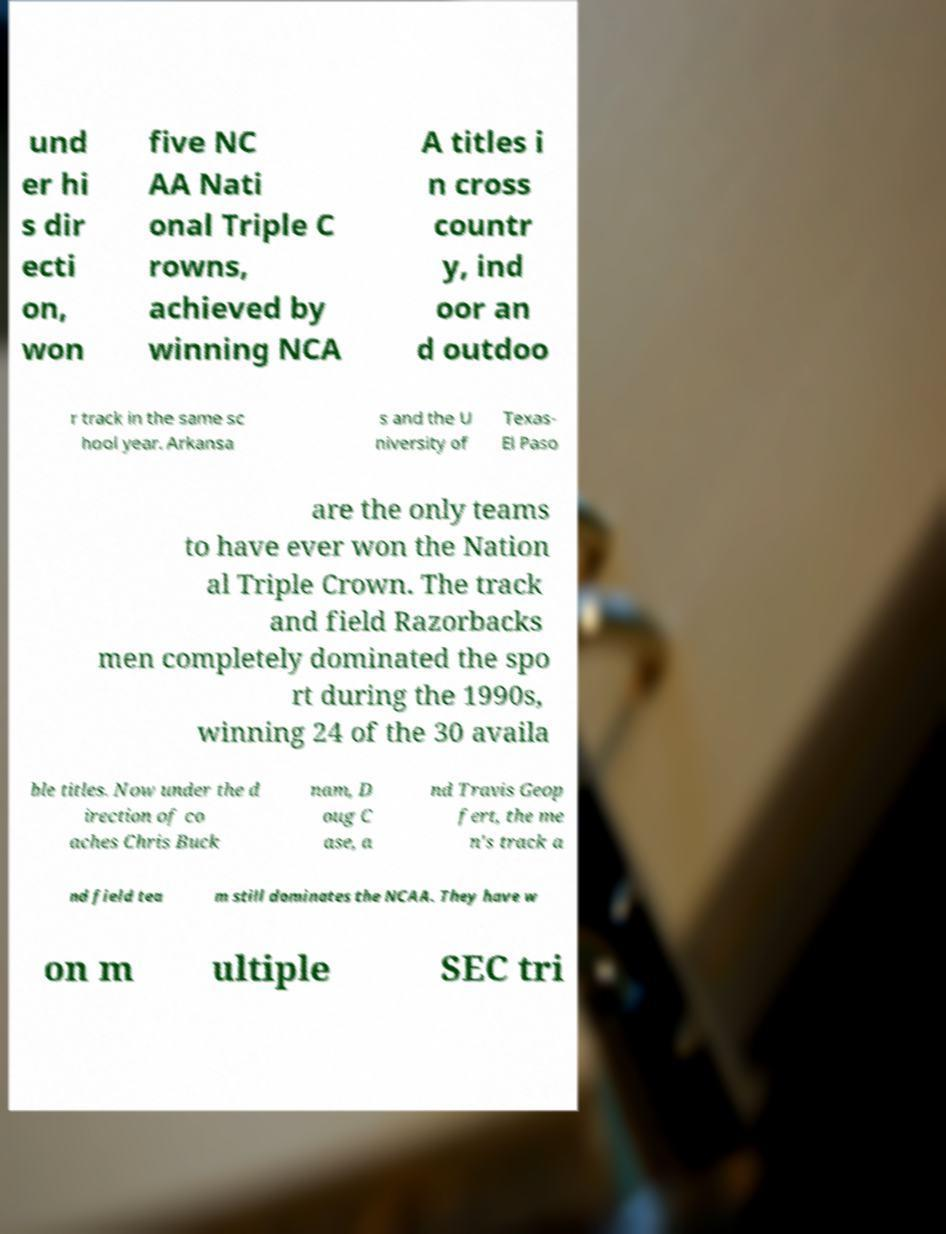Can you accurately transcribe the text from the provided image for me? und er hi s dir ecti on, won five NC AA Nati onal Triple C rowns, achieved by winning NCA A titles i n cross countr y, ind oor an d outdoo r track in the same sc hool year. Arkansa s and the U niversity of Texas- El Paso are the only teams to have ever won the Nation al Triple Crown. The track and field Razorbacks men completely dominated the spo rt during the 1990s, winning 24 of the 30 availa ble titles. Now under the d irection of co aches Chris Buck nam, D oug C ase, a nd Travis Geop fert, the me n's track a nd field tea m still dominates the NCAA. They have w on m ultiple SEC tri 